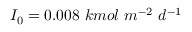<formula> <loc_0><loc_0><loc_500><loc_500>I _ { 0 } = 0 . 0 0 8 \ k m o l \ m ^ { - 2 } \ d ^ { - 1 }</formula> 